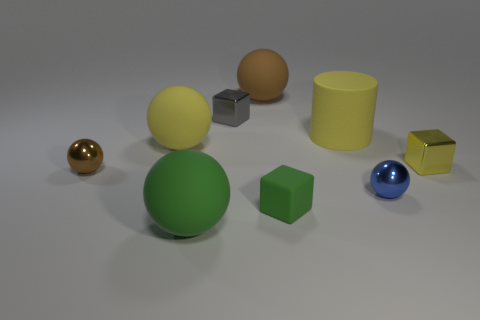Subtract all yellow rubber spheres. How many spheres are left? 4 Subtract 1 blocks. How many blocks are left? 2 Subtract all green spheres. How many spheres are left? 4 Subtract all gray spheres. Subtract all red blocks. How many spheres are left? 5 Add 1 small gray objects. How many objects exist? 10 Subtract all spheres. How many objects are left? 4 Subtract 1 yellow spheres. How many objects are left? 8 Subtract all large brown matte balls. Subtract all blocks. How many objects are left? 5 Add 4 cylinders. How many cylinders are left? 5 Add 7 small yellow cylinders. How many small yellow cylinders exist? 7 